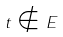<formula> <loc_0><loc_0><loc_500><loc_500>t \notin E</formula> 